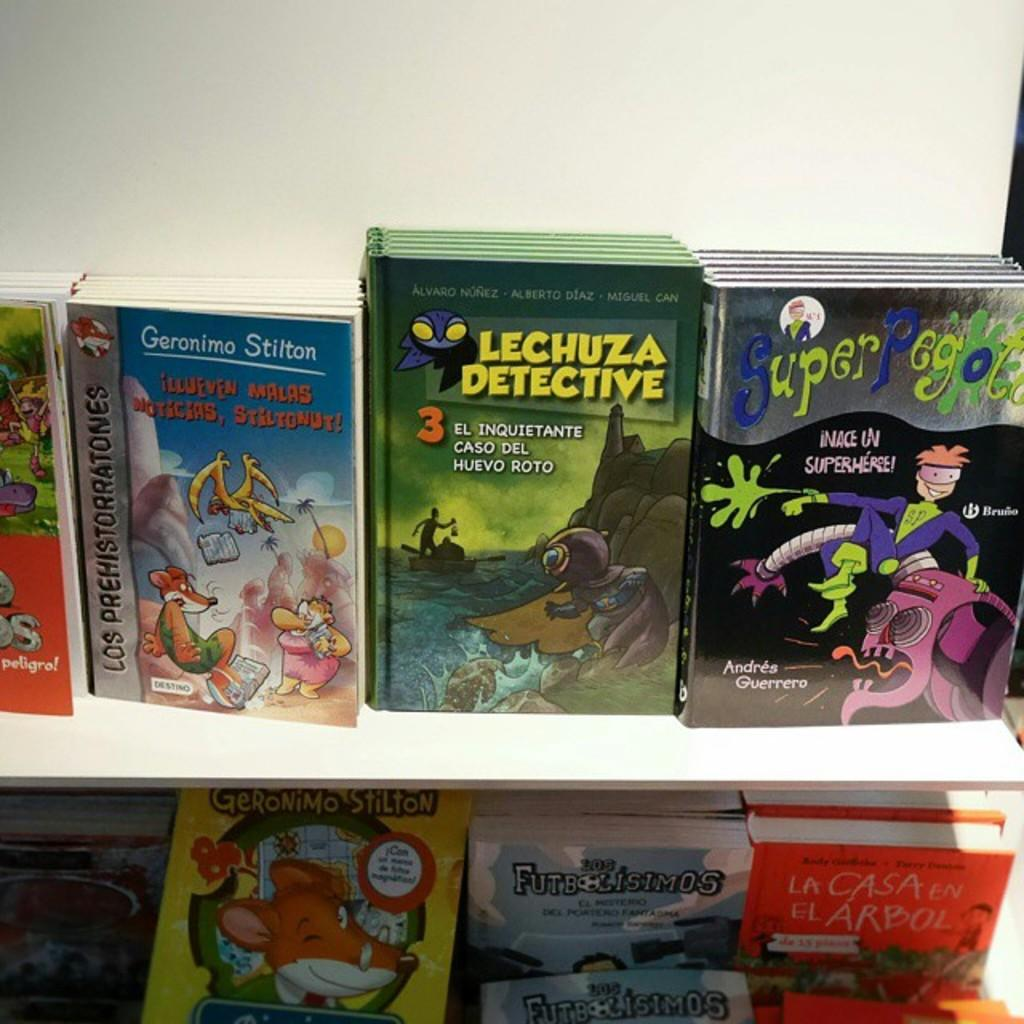<image>
Summarize the visual content of the image. A childrens book called La Casa En El Arbol is sitting among other books 